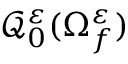Convert formula to latex. <formula><loc_0><loc_0><loc_500><loc_500>\mathcal { Q } _ { 0 } ^ { \varepsilon } ( \Omega _ { f } ^ { \varepsilon } )</formula> 